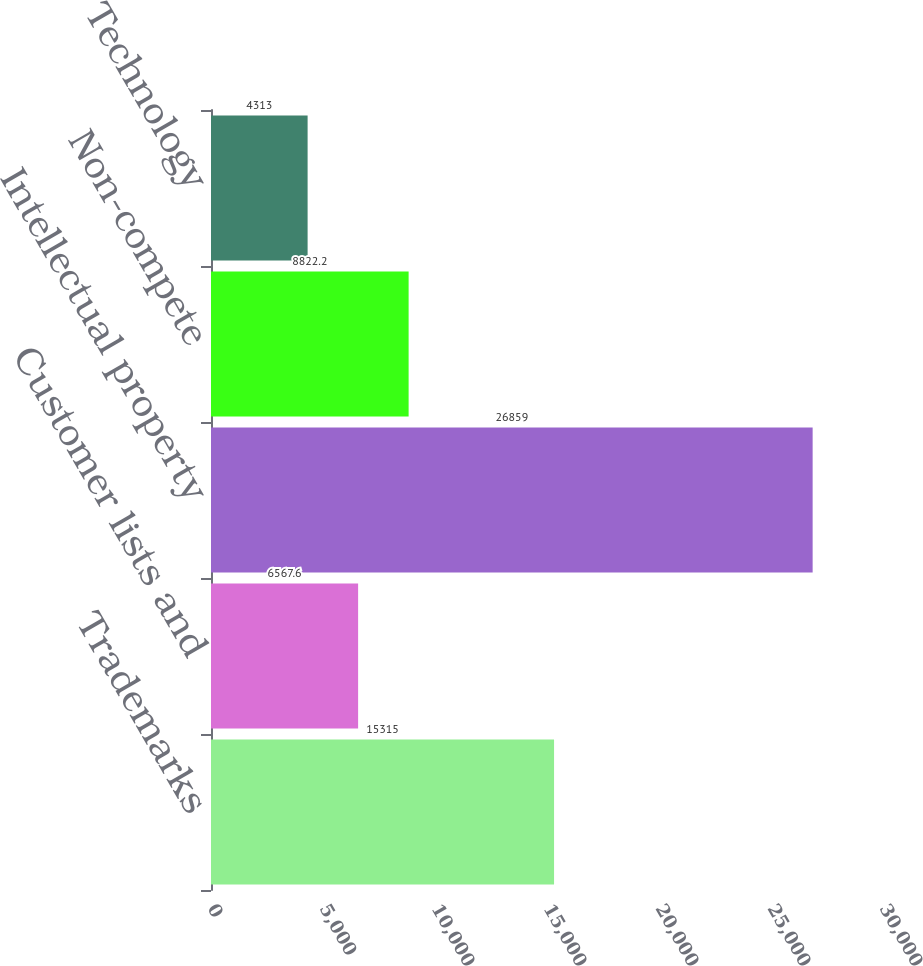Convert chart. <chart><loc_0><loc_0><loc_500><loc_500><bar_chart><fcel>Trademarks<fcel>Customer lists and<fcel>Intellectual property<fcel>Non-compete<fcel>Technology<nl><fcel>15315<fcel>6567.6<fcel>26859<fcel>8822.2<fcel>4313<nl></chart> 